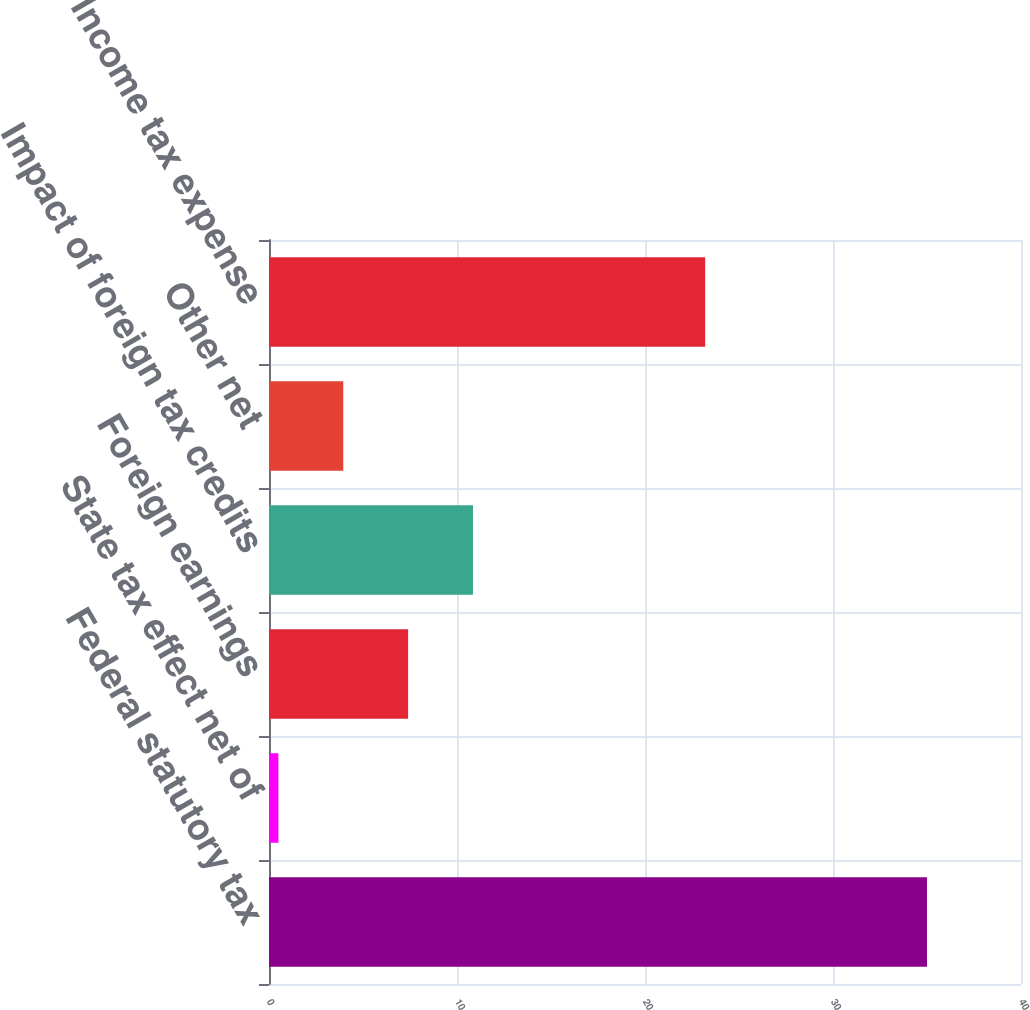<chart> <loc_0><loc_0><loc_500><loc_500><bar_chart><fcel>Federal statutory tax<fcel>State tax effect net of<fcel>Foreign earnings<fcel>Impact of foreign tax credits<fcel>Other net<fcel>Income tax expense<nl><fcel>35<fcel>0.5<fcel>7.4<fcel>10.85<fcel>3.95<fcel>23.2<nl></chart> 